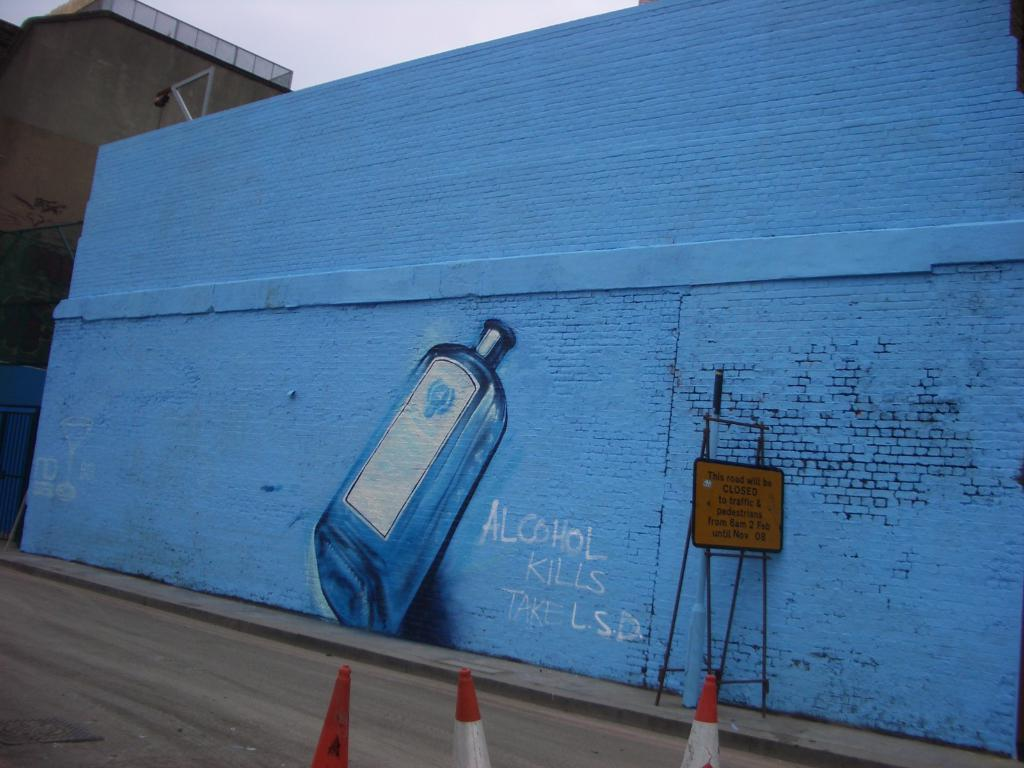Provide a one-sentence caption for the provided image. The graphiti says alcohol kills and to instead take LSD. 